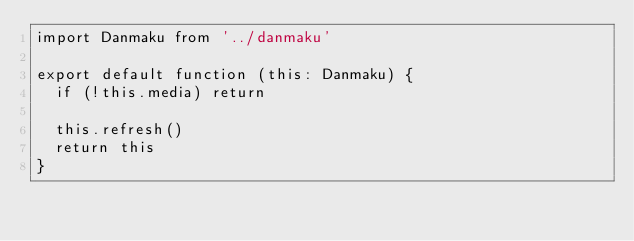Convert code to text. <code><loc_0><loc_0><loc_500><loc_500><_TypeScript_>import Danmaku from '../danmaku'

export default function (this: Danmaku) {
  if (!this.media) return

  this.refresh()
  return this
}
</code> 